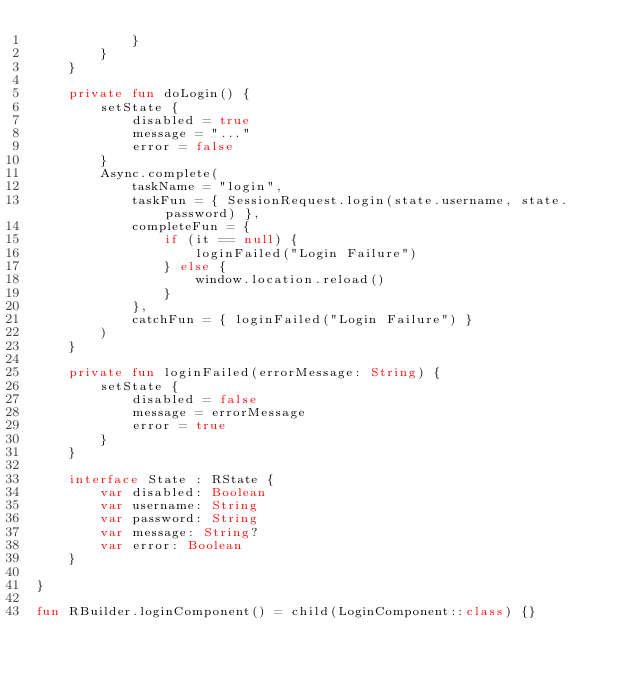Convert code to text. <code><loc_0><loc_0><loc_500><loc_500><_Kotlin_>            }
        }
    }

    private fun doLogin() {
        setState {
            disabled = true
            message = "..."
            error = false
        }
        Async.complete(
            taskName = "login",
            taskFun = { SessionRequest.login(state.username, state.password) },
            completeFun = {
                if (it == null) {
                    loginFailed("Login Failure")
                } else {
                    window.location.reload()
                }
            },
            catchFun = { loginFailed("Login Failure") }
        )
    }

    private fun loginFailed(errorMessage: String) {
        setState {
            disabled = false
            message = errorMessage
            error = true
        }
    }

    interface State : RState {
        var disabled: Boolean
        var username: String
        var password: String
        var message: String?
        var error: Boolean
    }

}

fun RBuilder.loginComponent() = child(LoginComponent::class) {}
</code> 